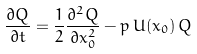Convert formula to latex. <formula><loc_0><loc_0><loc_500><loc_500>\frac { \partial Q } { \partial t } = \frac { 1 } { 2 } \frac { \partial ^ { 2 } Q } { \partial x _ { 0 } ^ { 2 } } - p \, U ( x _ { 0 } ) \, Q</formula> 